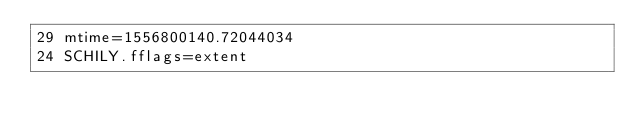<code> <loc_0><loc_0><loc_500><loc_500><_CSS_>29 mtime=1556800140.72044034
24 SCHILY.fflags=extent
</code> 